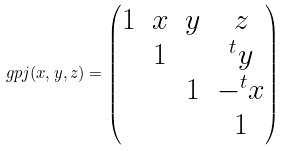<formula> <loc_0><loc_0><loc_500><loc_500>\ g p j ( x , y , z ) = \begin{pmatrix} 1 & x & y & z \\ & 1 & & ^ { t } y \\ & & 1 & - ^ { t } x \\ & & & 1 \end{pmatrix}</formula> 